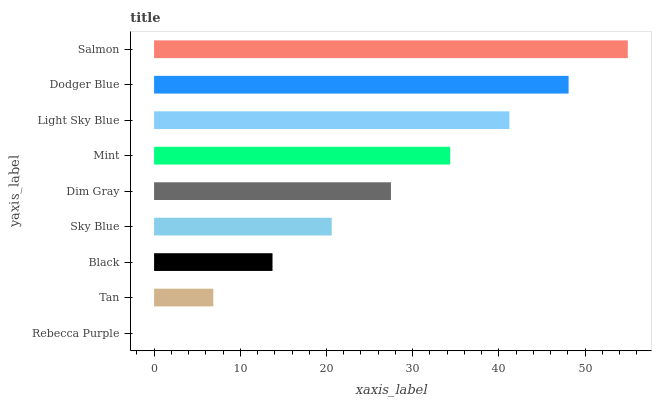Is Rebecca Purple the minimum?
Answer yes or no. Yes. Is Salmon the maximum?
Answer yes or no. Yes. Is Tan the minimum?
Answer yes or no. No. Is Tan the maximum?
Answer yes or no. No. Is Tan greater than Rebecca Purple?
Answer yes or no. Yes. Is Rebecca Purple less than Tan?
Answer yes or no. Yes. Is Rebecca Purple greater than Tan?
Answer yes or no. No. Is Tan less than Rebecca Purple?
Answer yes or no. No. Is Dim Gray the high median?
Answer yes or no. Yes. Is Dim Gray the low median?
Answer yes or no. Yes. Is Salmon the high median?
Answer yes or no. No. Is Black the low median?
Answer yes or no. No. 